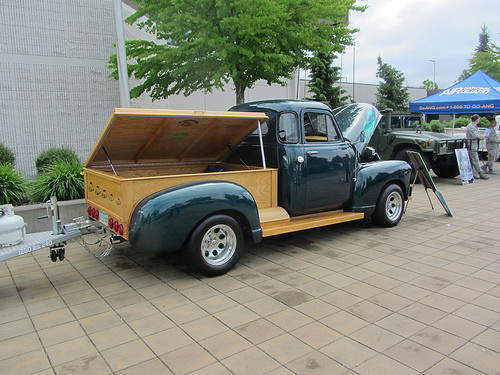<image>
Is there a car next to the human? No. The car is not positioned next to the human. They are located in different areas of the scene. Where is the car in relation to the tree? Is it in front of the tree? Yes. The car is positioned in front of the tree, appearing closer to the camera viewpoint. 